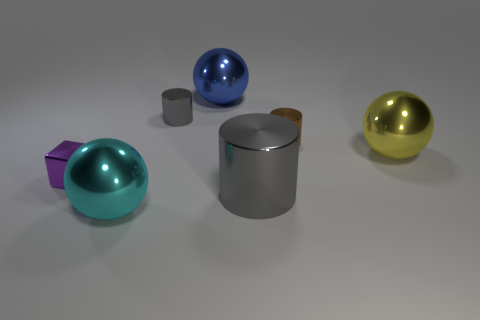What size is the yellow shiny thing that is the same shape as the cyan metal object?
Keep it short and to the point. Large. How many objects are either big blue cylinders or big yellow objects?
Give a very brief answer. 1. What number of gray cylinders are on the right side of the small cylinder that is left of the large gray cylinder?
Keep it short and to the point. 1. How many other things are there of the same size as the purple thing?
Ensure brevity in your answer.  2. Does the gray object that is behind the tiny purple metallic cube have the same shape as the tiny brown shiny thing?
Your answer should be very brief. Yes. Is there a large purple thing made of the same material as the big yellow thing?
Your response must be concise. No. The metallic block has what size?
Your answer should be very brief. Small. How many cyan objects are small objects or cylinders?
Give a very brief answer. 0. What number of other purple objects are the same shape as the purple metallic thing?
Make the answer very short. 0. What number of blue spheres have the same size as the yellow metal ball?
Your response must be concise. 1. 